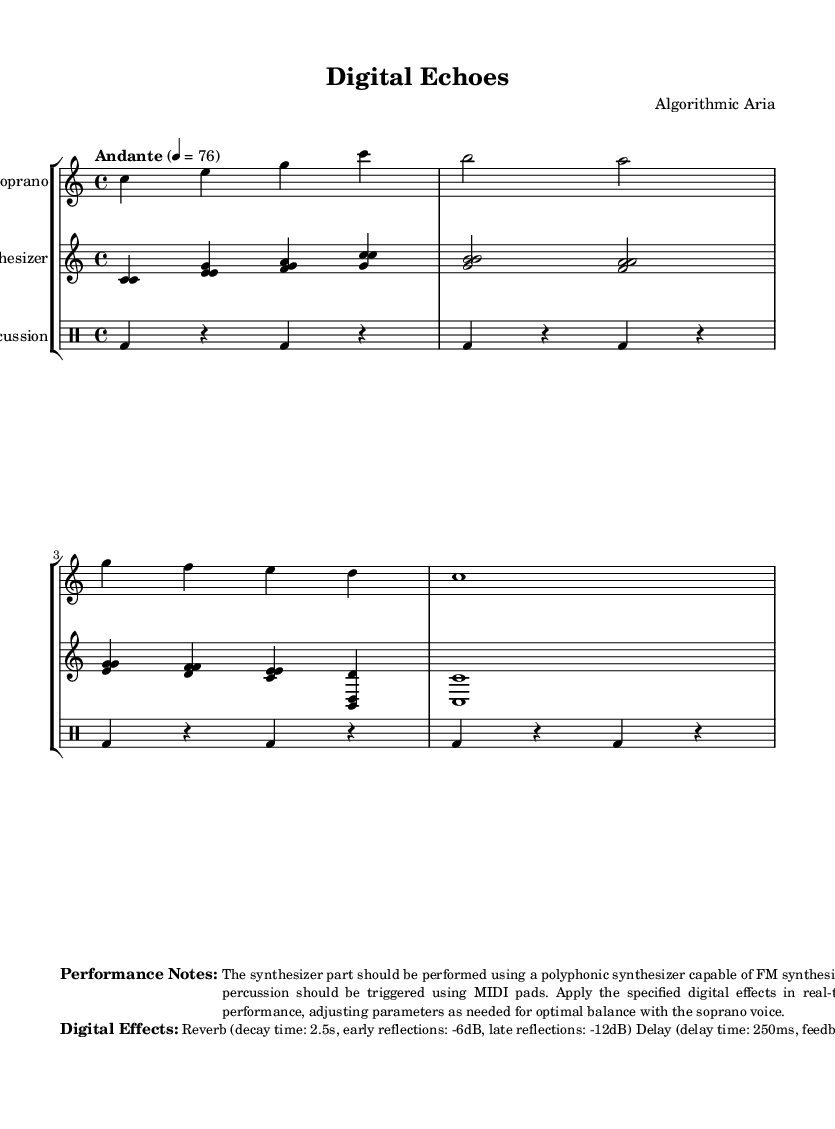What is the key signature of this music? The key signature is indicated by the absence of sharps or flats at the beginning of the score. This aligns with the C major key signature.
Answer: C major What is the time signature of this music? The time signature is presented after the key signature and is indicated as 4/4, which means there are four beats in a measure and a quarter note receives one beat.
Answer: 4/4 What is the tempo marking of this music? The tempo is located at the beginning of the score and indicates the speed of the piece; it states "Andante" with a metronome marking of 76, which denotes a moderate walking pace.
Answer: Andante 4 = 76 How many measures are in the soprano part? By counting the vertical lines (bar lines) in the soprano staff, including the last one, we find there are 5 measures in total.
Answer: 5 Which instrument is specified to use MIDI pads for performance? The performance notes explicitly mention that the electronic percussion part should be triggered using MIDI pads, indicating that this is the designated instrument for MIDI interaction.
Answer: Electronic Percussion What type of synthesis is specified for the synthesizer part? The performance notes state that the synthesizer should be capable of FM synthesis, which is a specific type of sound synthesis used to create complex sounds.
Answer: FM synthesis What digital effect is applied with a decay time of 2.5 seconds? The digital effects section notes that reverb is applied with a specified decay time of 2.5 seconds, which characterizes this effect within the performance.
Answer: Reverb 